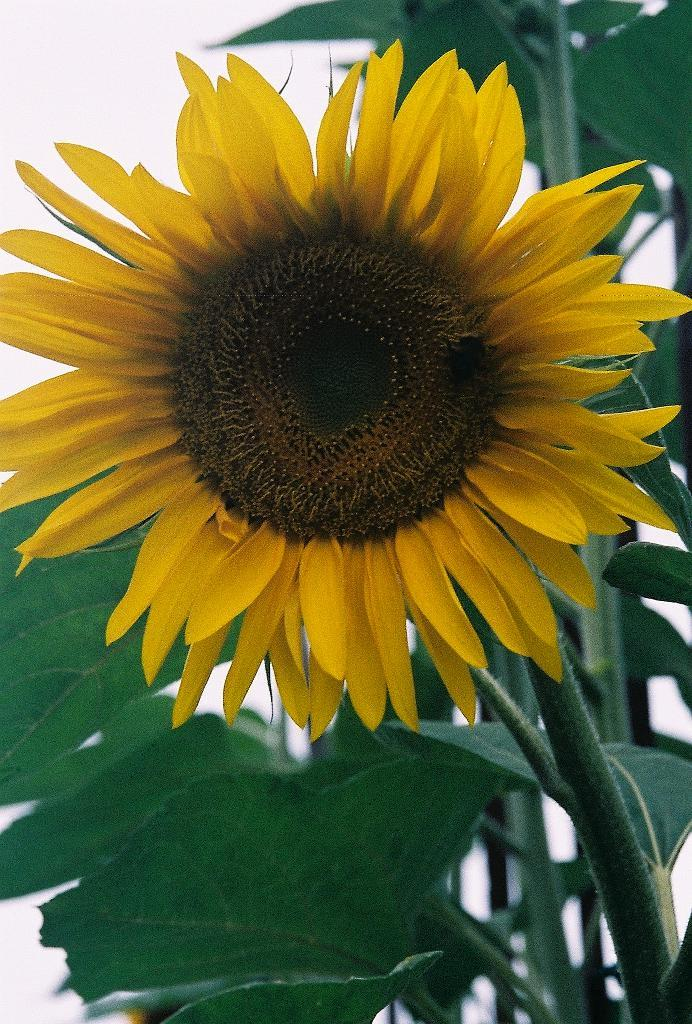What is the main subject in the front of the image? There is a sunflower in the front of the image. What can be seen in the background of the image? There are green leaves in the background of the image. How many ladybugs can be seen on the sunflower in the image? There are no ladybugs present in the image; it only features a sunflower and green leaves. 